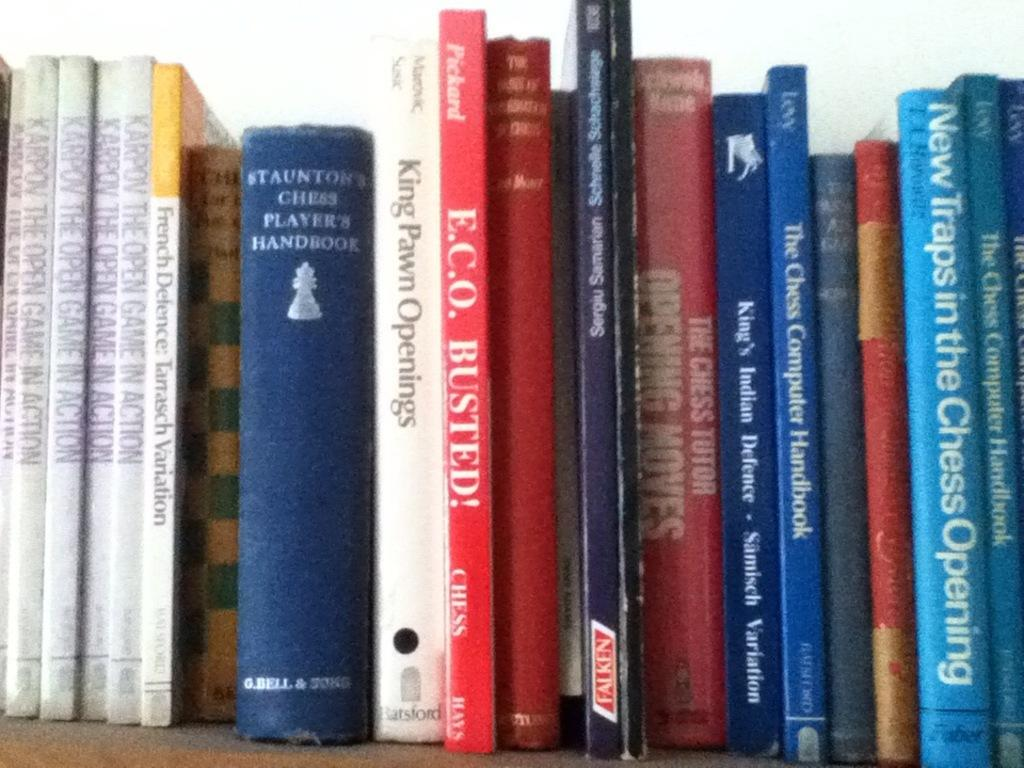<image>
Describe the image concisely. Several books about chess and how to play it are on a shelf 